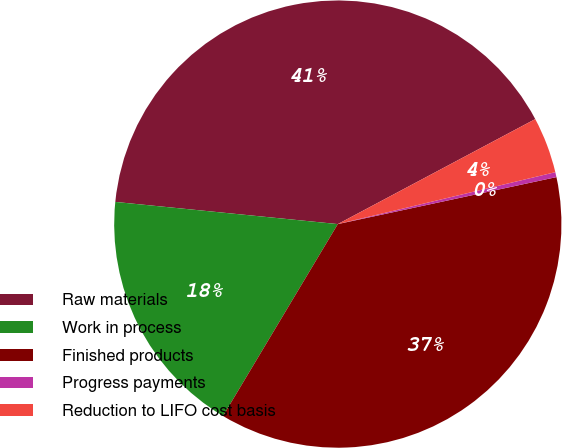Convert chart. <chart><loc_0><loc_0><loc_500><loc_500><pie_chart><fcel>Raw materials<fcel>Work in process<fcel>Finished products<fcel>Progress payments<fcel>Reduction to LIFO cost basis<nl><fcel>40.64%<fcel>18.0%<fcel>36.95%<fcel>0.36%<fcel>4.05%<nl></chart> 